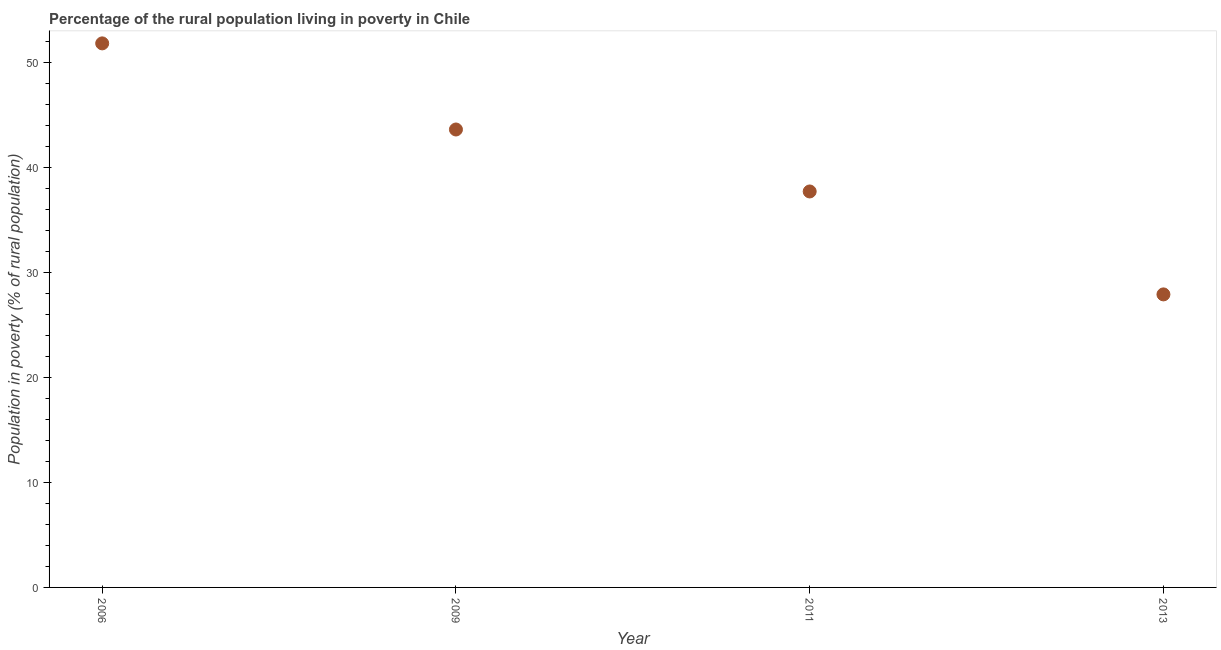What is the percentage of rural population living below poverty line in 2009?
Keep it short and to the point. 43.6. Across all years, what is the maximum percentage of rural population living below poverty line?
Ensure brevity in your answer.  51.8. Across all years, what is the minimum percentage of rural population living below poverty line?
Provide a short and direct response. 27.9. What is the sum of the percentage of rural population living below poverty line?
Your answer should be compact. 161. What is the difference between the percentage of rural population living below poverty line in 2006 and 2009?
Give a very brief answer. 8.2. What is the average percentage of rural population living below poverty line per year?
Keep it short and to the point. 40.25. What is the median percentage of rural population living below poverty line?
Ensure brevity in your answer.  40.65. What is the ratio of the percentage of rural population living below poverty line in 2006 to that in 2013?
Keep it short and to the point. 1.86. Is the percentage of rural population living below poverty line in 2006 less than that in 2011?
Ensure brevity in your answer.  No. What is the difference between the highest and the second highest percentage of rural population living below poverty line?
Give a very brief answer. 8.2. What is the difference between the highest and the lowest percentage of rural population living below poverty line?
Ensure brevity in your answer.  23.9. In how many years, is the percentage of rural population living below poverty line greater than the average percentage of rural population living below poverty line taken over all years?
Make the answer very short. 2. Does the percentage of rural population living below poverty line monotonically increase over the years?
Offer a very short reply. No. What is the difference between two consecutive major ticks on the Y-axis?
Your response must be concise. 10. Does the graph contain grids?
Ensure brevity in your answer.  No. What is the title of the graph?
Offer a terse response. Percentage of the rural population living in poverty in Chile. What is the label or title of the X-axis?
Give a very brief answer. Year. What is the label or title of the Y-axis?
Your answer should be compact. Population in poverty (% of rural population). What is the Population in poverty (% of rural population) in 2006?
Ensure brevity in your answer.  51.8. What is the Population in poverty (% of rural population) in 2009?
Give a very brief answer. 43.6. What is the Population in poverty (% of rural population) in 2011?
Your answer should be very brief. 37.7. What is the Population in poverty (% of rural population) in 2013?
Offer a terse response. 27.9. What is the difference between the Population in poverty (% of rural population) in 2006 and 2009?
Give a very brief answer. 8.2. What is the difference between the Population in poverty (% of rural population) in 2006 and 2011?
Offer a terse response. 14.1. What is the difference between the Population in poverty (% of rural population) in 2006 and 2013?
Ensure brevity in your answer.  23.9. What is the difference between the Population in poverty (% of rural population) in 2009 and 2013?
Keep it short and to the point. 15.7. What is the ratio of the Population in poverty (% of rural population) in 2006 to that in 2009?
Offer a terse response. 1.19. What is the ratio of the Population in poverty (% of rural population) in 2006 to that in 2011?
Keep it short and to the point. 1.37. What is the ratio of the Population in poverty (% of rural population) in 2006 to that in 2013?
Provide a short and direct response. 1.86. What is the ratio of the Population in poverty (% of rural population) in 2009 to that in 2011?
Your response must be concise. 1.16. What is the ratio of the Population in poverty (% of rural population) in 2009 to that in 2013?
Your answer should be compact. 1.56. What is the ratio of the Population in poverty (% of rural population) in 2011 to that in 2013?
Your answer should be very brief. 1.35. 